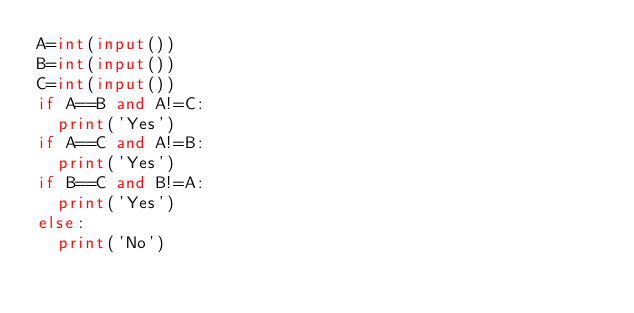<code> <loc_0><loc_0><loc_500><loc_500><_Python_>A=int(input())
B=int(input())
C=int(input())
if A==B and A!=C:
  print('Yes')
if A==C and A!=B: 
  print('Yes')
if B==C and B!=A: 
  print('Yes')
else: 
  print('No')</code> 